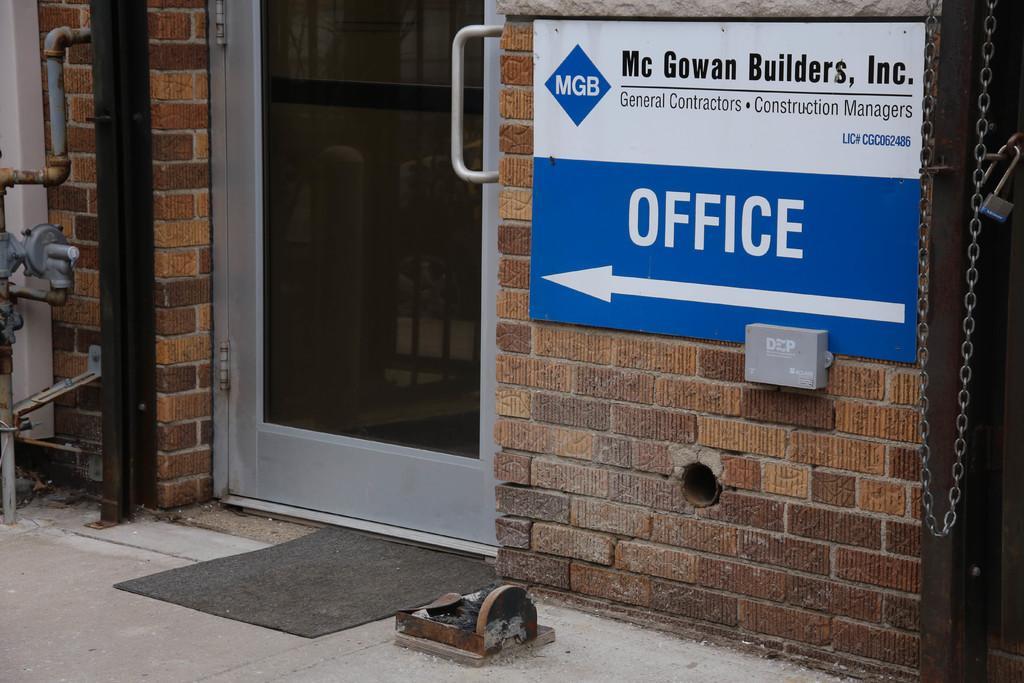Describe this image in one or two sentences. In this picture we can see door, handle, board, wall, poles, pipes, machine, chain rod, lock, mat. At the bottom of the image there is a floor. 